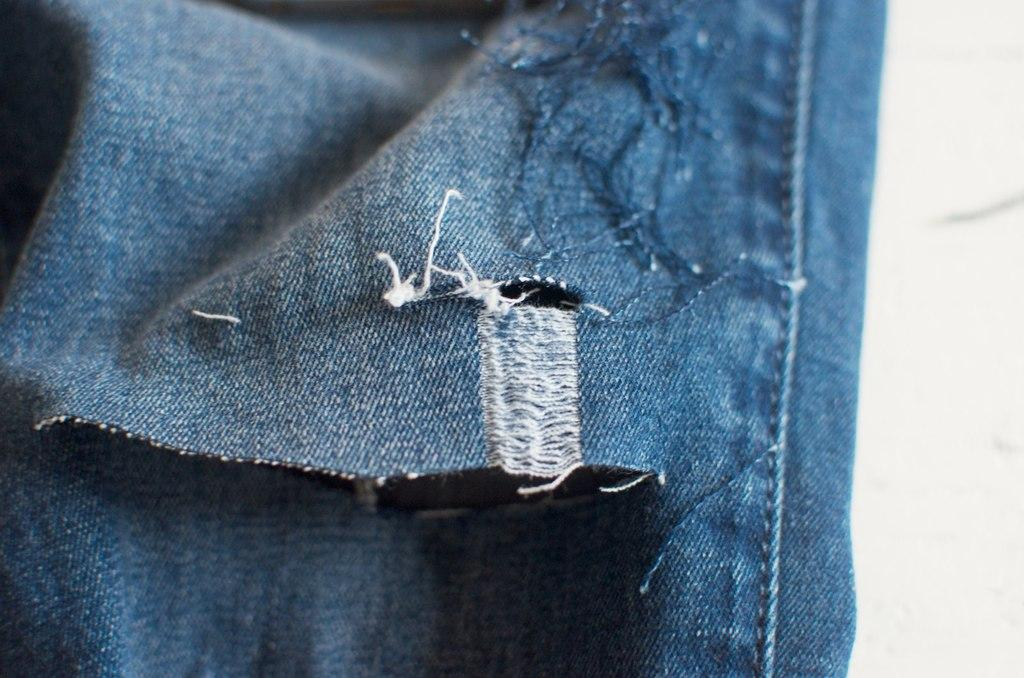What is the main subject of the image? The main subject of the image is a zoomed in picture of jeans. Can you describe the surroundings of the jeans in the image? There is a wall on the right side of the image. How many apples are hanging from the tree in the image? There is no tree or apples present in the image; it features a zoomed in picture of jeans with a wall on the right side. 